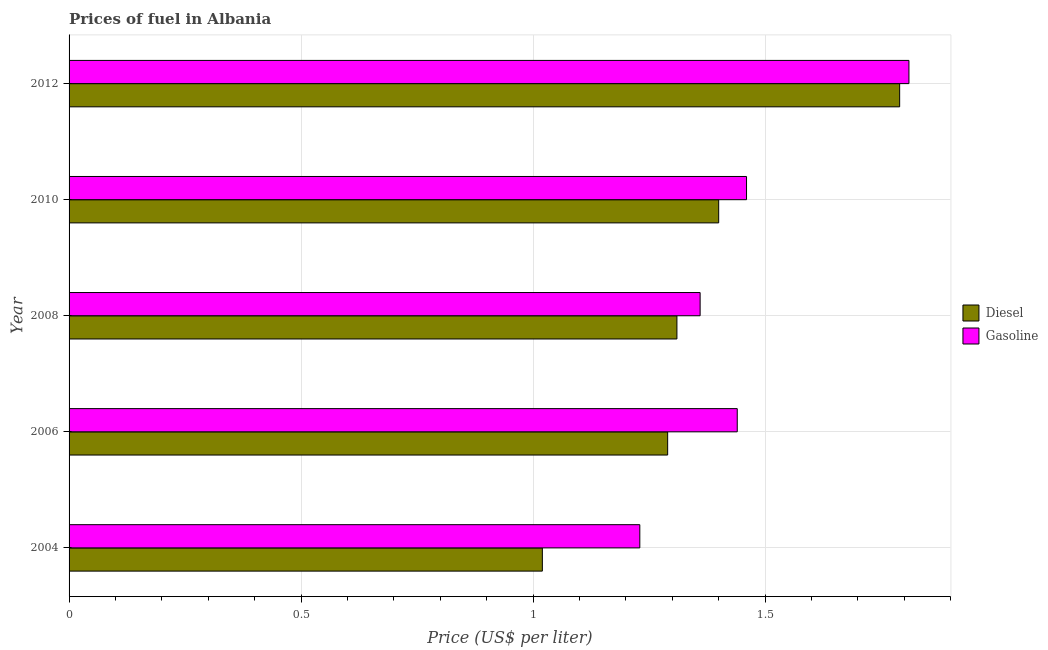How many bars are there on the 1st tick from the top?
Offer a terse response. 2. How many bars are there on the 4th tick from the bottom?
Make the answer very short. 2. What is the label of the 1st group of bars from the top?
Your response must be concise. 2012. What is the gasoline price in 2010?
Your answer should be very brief. 1.46. Across all years, what is the maximum gasoline price?
Provide a succinct answer. 1.81. In which year was the diesel price minimum?
Offer a terse response. 2004. What is the total diesel price in the graph?
Give a very brief answer. 6.81. What is the difference between the diesel price in 2006 and that in 2008?
Offer a terse response. -0.02. What is the difference between the diesel price in 2010 and the gasoline price in 2012?
Make the answer very short. -0.41. What is the average diesel price per year?
Provide a succinct answer. 1.36. In the year 2006, what is the difference between the diesel price and gasoline price?
Your answer should be compact. -0.15. In how many years, is the diesel price greater than 1 US$ per litre?
Offer a very short reply. 5. What is the ratio of the gasoline price in 2004 to that in 2008?
Make the answer very short. 0.9. Is the diesel price in 2006 less than that in 2010?
Your response must be concise. Yes. Is the difference between the diesel price in 2006 and 2010 greater than the difference between the gasoline price in 2006 and 2010?
Provide a succinct answer. No. What is the difference between the highest and the lowest diesel price?
Ensure brevity in your answer.  0.77. Is the sum of the gasoline price in 2006 and 2010 greater than the maximum diesel price across all years?
Ensure brevity in your answer.  Yes. What does the 2nd bar from the top in 2006 represents?
Keep it short and to the point. Diesel. What does the 2nd bar from the bottom in 2004 represents?
Keep it short and to the point. Gasoline. How many years are there in the graph?
Offer a terse response. 5. Are the values on the major ticks of X-axis written in scientific E-notation?
Provide a short and direct response. No. Does the graph contain any zero values?
Provide a short and direct response. No. Does the graph contain grids?
Keep it short and to the point. Yes. Where does the legend appear in the graph?
Your response must be concise. Center right. What is the title of the graph?
Your response must be concise. Prices of fuel in Albania. What is the label or title of the X-axis?
Provide a succinct answer. Price (US$ per liter). What is the label or title of the Y-axis?
Your answer should be compact. Year. What is the Price (US$ per liter) of Gasoline in 2004?
Provide a short and direct response. 1.23. What is the Price (US$ per liter) in Diesel in 2006?
Offer a terse response. 1.29. What is the Price (US$ per liter) of Gasoline in 2006?
Ensure brevity in your answer.  1.44. What is the Price (US$ per liter) of Diesel in 2008?
Your answer should be very brief. 1.31. What is the Price (US$ per liter) in Gasoline in 2008?
Make the answer very short. 1.36. What is the Price (US$ per liter) of Gasoline in 2010?
Your response must be concise. 1.46. What is the Price (US$ per liter) of Diesel in 2012?
Make the answer very short. 1.79. What is the Price (US$ per liter) of Gasoline in 2012?
Your answer should be compact. 1.81. Across all years, what is the maximum Price (US$ per liter) in Diesel?
Offer a very short reply. 1.79. Across all years, what is the maximum Price (US$ per liter) in Gasoline?
Provide a short and direct response. 1.81. Across all years, what is the minimum Price (US$ per liter) of Diesel?
Give a very brief answer. 1.02. Across all years, what is the minimum Price (US$ per liter) in Gasoline?
Provide a succinct answer. 1.23. What is the total Price (US$ per liter) of Diesel in the graph?
Offer a very short reply. 6.81. What is the difference between the Price (US$ per liter) in Diesel in 2004 and that in 2006?
Offer a very short reply. -0.27. What is the difference between the Price (US$ per liter) in Gasoline in 2004 and that in 2006?
Your answer should be very brief. -0.21. What is the difference between the Price (US$ per liter) in Diesel in 2004 and that in 2008?
Provide a succinct answer. -0.29. What is the difference between the Price (US$ per liter) in Gasoline in 2004 and that in 2008?
Your answer should be compact. -0.13. What is the difference between the Price (US$ per liter) of Diesel in 2004 and that in 2010?
Offer a terse response. -0.38. What is the difference between the Price (US$ per liter) in Gasoline in 2004 and that in 2010?
Offer a very short reply. -0.23. What is the difference between the Price (US$ per liter) of Diesel in 2004 and that in 2012?
Offer a terse response. -0.77. What is the difference between the Price (US$ per liter) in Gasoline in 2004 and that in 2012?
Make the answer very short. -0.58. What is the difference between the Price (US$ per liter) in Diesel in 2006 and that in 2008?
Your answer should be very brief. -0.02. What is the difference between the Price (US$ per liter) in Gasoline in 2006 and that in 2008?
Provide a succinct answer. 0.08. What is the difference between the Price (US$ per liter) in Diesel in 2006 and that in 2010?
Ensure brevity in your answer.  -0.11. What is the difference between the Price (US$ per liter) of Gasoline in 2006 and that in 2010?
Your answer should be compact. -0.02. What is the difference between the Price (US$ per liter) of Gasoline in 2006 and that in 2012?
Your answer should be compact. -0.37. What is the difference between the Price (US$ per liter) in Diesel in 2008 and that in 2010?
Make the answer very short. -0.09. What is the difference between the Price (US$ per liter) of Diesel in 2008 and that in 2012?
Keep it short and to the point. -0.48. What is the difference between the Price (US$ per liter) in Gasoline in 2008 and that in 2012?
Your answer should be compact. -0.45. What is the difference between the Price (US$ per liter) of Diesel in 2010 and that in 2012?
Your answer should be very brief. -0.39. What is the difference between the Price (US$ per liter) of Gasoline in 2010 and that in 2012?
Provide a short and direct response. -0.35. What is the difference between the Price (US$ per liter) of Diesel in 2004 and the Price (US$ per liter) of Gasoline in 2006?
Make the answer very short. -0.42. What is the difference between the Price (US$ per liter) in Diesel in 2004 and the Price (US$ per liter) in Gasoline in 2008?
Ensure brevity in your answer.  -0.34. What is the difference between the Price (US$ per liter) in Diesel in 2004 and the Price (US$ per liter) in Gasoline in 2010?
Provide a succinct answer. -0.44. What is the difference between the Price (US$ per liter) in Diesel in 2004 and the Price (US$ per liter) in Gasoline in 2012?
Offer a very short reply. -0.79. What is the difference between the Price (US$ per liter) of Diesel in 2006 and the Price (US$ per liter) of Gasoline in 2008?
Your answer should be very brief. -0.07. What is the difference between the Price (US$ per liter) of Diesel in 2006 and the Price (US$ per liter) of Gasoline in 2010?
Ensure brevity in your answer.  -0.17. What is the difference between the Price (US$ per liter) in Diesel in 2006 and the Price (US$ per liter) in Gasoline in 2012?
Your answer should be compact. -0.52. What is the difference between the Price (US$ per liter) in Diesel in 2008 and the Price (US$ per liter) in Gasoline in 2010?
Offer a very short reply. -0.15. What is the difference between the Price (US$ per liter) in Diesel in 2008 and the Price (US$ per liter) in Gasoline in 2012?
Keep it short and to the point. -0.5. What is the difference between the Price (US$ per liter) in Diesel in 2010 and the Price (US$ per liter) in Gasoline in 2012?
Provide a succinct answer. -0.41. What is the average Price (US$ per liter) of Diesel per year?
Offer a very short reply. 1.36. What is the average Price (US$ per liter) of Gasoline per year?
Keep it short and to the point. 1.46. In the year 2004, what is the difference between the Price (US$ per liter) of Diesel and Price (US$ per liter) of Gasoline?
Make the answer very short. -0.21. In the year 2010, what is the difference between the Price (US$ per liter) in Diesel and Price (US$ per liter) in Gasoline?
Ensure brevity in your answer.  -0.06. In the year 2012, what is the difference between the Price (US$ per liter) of Diesel and Price (US$ per liter) of Gasoline?
Make the answer very short. -0.02. What is the ratio of the Price (US$ per liter) of Diesel in 2004 to that in 2006?
Provide a succinct answer. 0.79. What is the ratio of the Price (US$ per liter) of Gasoline in 2004 to that in 2006?
Make the answer very short. 0.85. What is the ratio of the Price (US$ per liter) of Diesel in 2004 to that in 2008?
Your response must be concise. 0.78. What is the ratio of the Price (US$ per liter) of Gasoline in 2004 to that in 2008?
Offer a very short reply. 0.9. What is the ratio of the Price (US$ per liter) of Diesel in 2004 to that in 2010?
Your response must be concise. 0.73. What is the ratio of the Price (US$ per liter) of Gasoline in 2004 to that in 2010?
Keep it short and to the point. 0.84. What is the ratio of the Price (US$ per liter) of Diesel in 2004 to that in 2012?
Ensure brevity in your answer.  0.57. What is the ratio of the Price (US$ per liter) of Gasoline in 2004 to that in 2012?
Offer a very short reply. 0.68. What is the ratio of the Price (US$ per liter) of Diesel in 2006 to that in 2008?
Your answer should be very brief. 0.98. What is the ratio of the Price (US$ per liter) of Gasoline in 2006 to that in 2008?
Provide a short and direct response. 1.06. What is the ratio of the Price (US$ per liter) of Diesel in 2006 to that in 2010?
Your answer should be compact. 0.92. What is the ratio of the Price (US$ per liter) of Gasoline in 2006 to that in 2010?
Keep it short and to the point. 0.99. What is the ratio of the Price (US$ per liter) of Diesel in 2006 to that in 2012?
Provide a succinct answer. 0.72. What is the ratio of the Price (US$ per liter) of Gasoline in 2006 to that in 2012?
Offer a terse response. 0.8. What is the ratio of the Price (US$ per liter) in Diesel in 2008 to that in 2010?
Make the answer very short. 0.94. What is the ratio of the Price (US$ per liter) of Gasoline in 2008 to that in 2010?
Make the answer very short. 0.93. What is the ratio of the Price (US$ per liter) in Diesel in 2008 to that in 2012?
Provide a succinct answer. 0.73. What is the ratio of the Price (US$ per liter) in Gasoline in 2008 to that in 2012?
Your response must be concise. 0.75. What is the ratio of the Price (US$ per liter) in Diesel in 2010 to that in 2012?
Your answer should be very brief. 0.78. What is the ratio of the Price (US$ per liter) of Gasoline in 2010 to that in 2012?
Provide a succinct answer. 0.81. What is the difference between the highest and the second highest Price (US$ per liter) of Diesel?
Offer a very short reply. 0.39. What is the difference between the highest and the second highest Price (US$ per liter) in Gasoline?
Offer a very short reply. 0.35. What is the difference between the highest and the lowest Price (US$ per liter) in Diesel?
Give a very brief answer. 0.77. What is the difference between the highest and the lowest Price (US$ per liter) of Gasoline?
Provide a short and direct response. 0.58. 